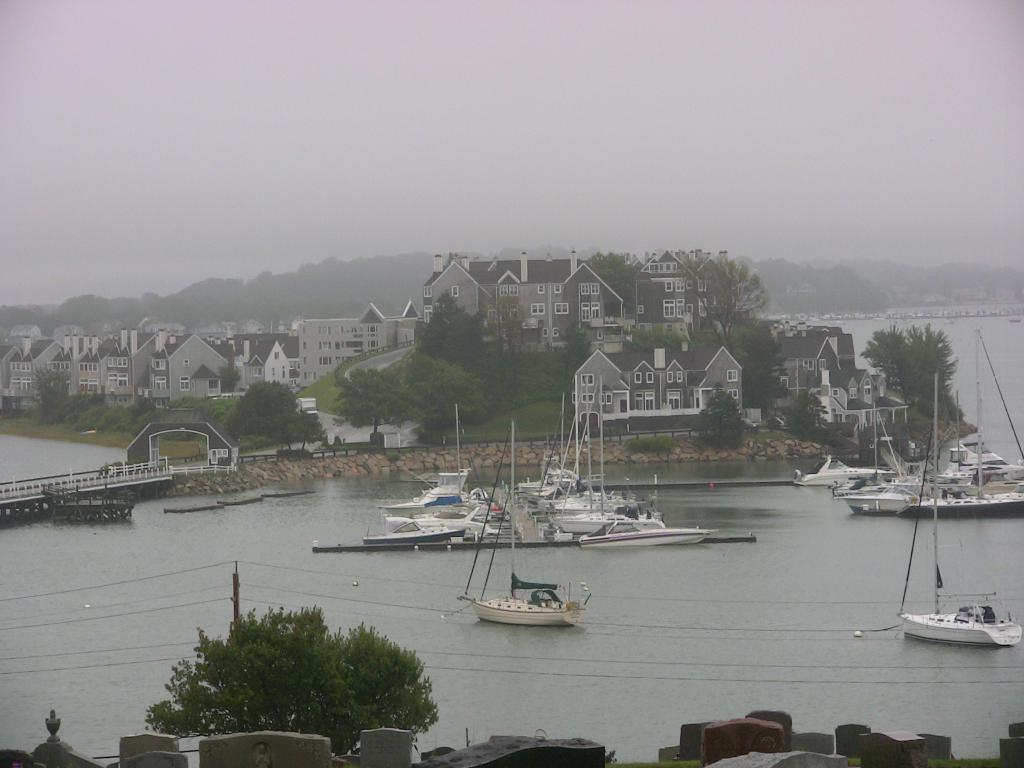What type of vehicles can be seen in the water in the image? There are ships in the water in the image. What structure can be seen connecting two areas in the image? There is a bridge in the image. What type of man-made structures are visible in the image? There are buildings in the image. What type of natural vegetation is present in the image? Trees are present in the image. What type of geographical feature can be seen in the image? There are mountains covered with snow in the image. How many boys are playing in the spring near the fish in the image? There are no boys, spring, or fish present in the image. 